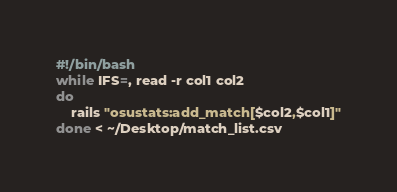<code> <loc_0><loc_0><loc_500><loc_500><_Bash_>
#!/bin/bash
while IFS=, read -r col1 col2
do
    rails "osustats:add_match[$col2,$col1]"
done < ~/Desktop/match_list.csv
</code> 